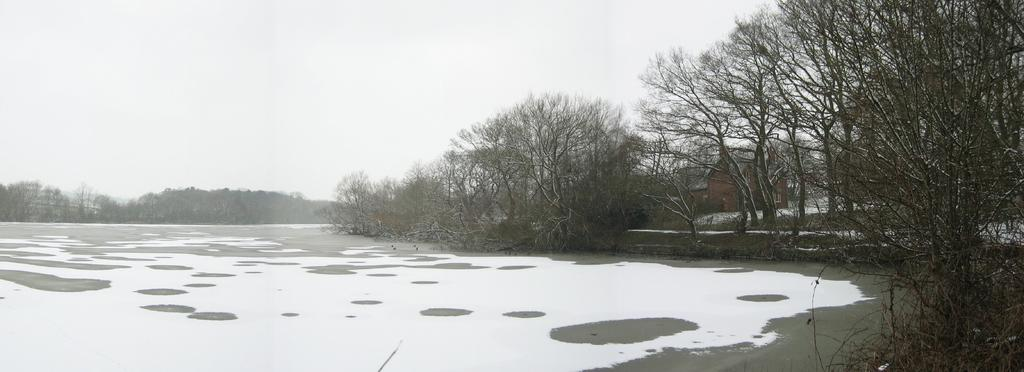What type of vegetation can be seen in the image? There are trees in the image. What else can be seen on the ground in the image? There is grass in the image. What is visible in the image besides the trees and grass? There is water visible in the image. What can be seen in the background of the image? There is a house in the background of the image. What is visible at the top of the image? The sky is visible at the top of the image. What type of feast is being prepared in the image? There is no indication of a feast or any food preparation in the image. What is the process for growing the trees in the image? The image does not provide information about the process of growing the trees. 